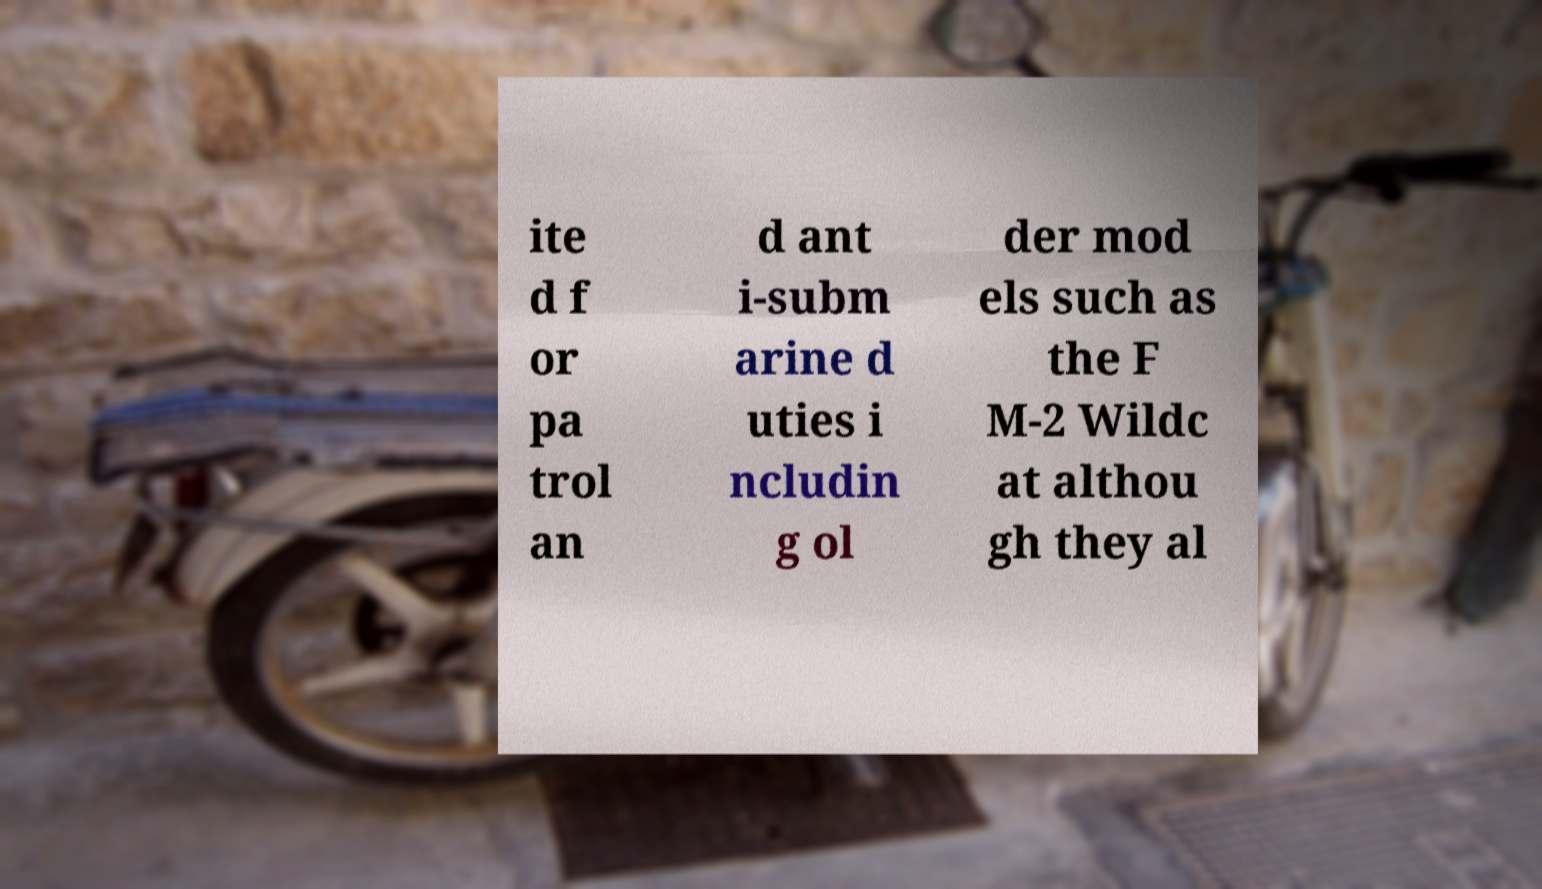Can you read and provide the text displayed in the image?This photo seems to have some interesting text. Can you extract and type it out for me? ite d f or pa trol an d ant i-subm arine d uties i ncludin g ol der mod els such as the F M-2 Wildc at althou gh they al 